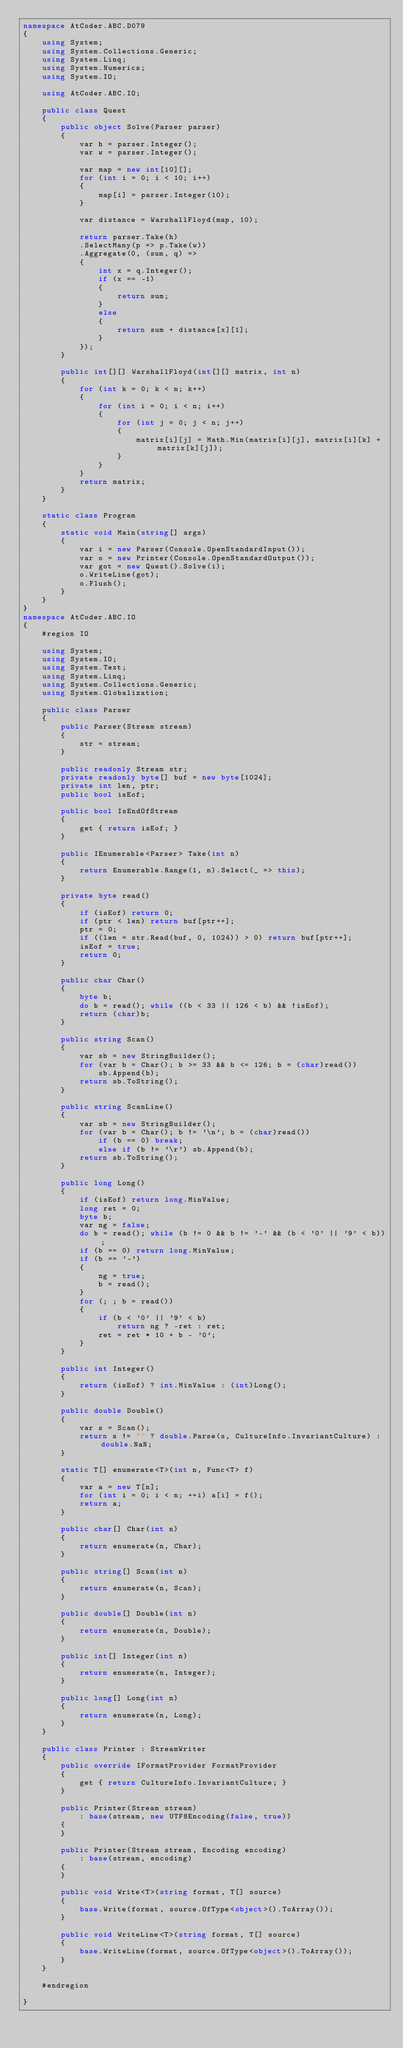<code> <loc_0><loc_0><loc_500><loc_500><_C#_>namespace AtCoder.ABC.D079
{
    using System;
    using System.Collections.Generic;
    using System.Linq;
    using System.Numerics;
    using System.IO;

    using AtCoder.ABC.IO;

    public class Quest
    {
        public object Solve(Parser parser)
        {
            var h = parser.Integer();
            var w = parser.Integer();

            var map = new int[10][];
            for (int i = 0; i < 10; i++)
            {
                map[i] = parser.Integer(10);
            }

            var distance = WarshallFloyd(map, 10);

            return parser.Take(h)
            .SelectMany(p => p.Take(w))
            .Aggregate(0, (sum, q) =>
            {
                int x = q.Integer();
                if (x == -1)
                {
                    return sum;
                }
                else
                {
                    return sum + distance[x][1];
                }
            });
        }

        public int[][] WarshallFloyd(int[][] matrix, int n)
        {
            for (int k = 0; k < n; k++)
            {
                for (int i = 0; i < n; i++)
                {
                    for (int j = 0; j < n; j++)
                    {
                        matrix[i][j] = Math.Min(matrix[i][j], matrix[i][k] + matrix[k][j]);
                    }
                }
            }
            return matrix;
        }
    }

    static class Program
    {
        static void Main(string[] args)
        {
            var i = new Parser(Console.OpenStandardInput());
            var o = new Printer(Console.OpenStandardOutput());
            var got = new Quest().Solve(i);
            o.WriteLine(got);
            o.Flush();
        }
    }
}
namespace AtCoder.ABC.IO
{
    #region IO

    using System;
    using System.IO;
    using System.Text;
    using System.Linq;
    using System.Collections.Generic;
    using System.Globalization;

    public class Parser
    {
        public Parser(Stream stream)
        {
            str = stream;
        }

        public readonly Stream str;
        private readonly byte[] buf = new byte[1024];
        private int len, ptr;
        public bool isEof;

        public bool IsEndOfStream
        {
            get { return isEof; }
        }

        public IEnumerable<Parser> Take(int n)
        {
            return Enumerable.Range(1, n).Select(_ => this);
        }

        private byte read()
        {
            if (isEof) return 0;
            if (ptr < len) return buf[ptr++];
            ptr = 0;
            if ((len = str.Read(buf, 0, 1024)) > 0) return buf[ptr++];
            isEof = true;
            return 0;
        }

        public char Char()
        {
            byte b;
            do b = read(); while ((b < 33 || 126 < b) && !isEof);
            return (char)b;
        }

        public string Scan()
        {
            var sb = new StringBuilder();
            for (var b = Char(); b >= 33 && b <= 126; b = (char)read())
                sb.Append(b);
            return sb.ToString();
        }

        public string ScanLine()
        {
            var sb = new StringBuilder();
            for (var b = Char(); b != '\n'; b = (char)read())
                if (b == 0) break;
                else if (b != '\r') sb.Append(b);
            return sb.ToString();
        }

        public long Long()
        {
            if (isEof) return long.MinValue;
            long ret = 0;
            byte b;
            var ng = false;
            do b = read(); while (b != 0 && b != '-' && (b < '0' || '9' < b));
            if (b == 0) return long.MinValue;
            if (b == '-')
            {
                ng = true;
                b = read();
            }
            for (; ; b = read())
            {
                if (b < '0' || '9' < b)
                    return ng ? -ret : ret;
                ret = ret * 10 + b - '0';
            }
        }

        public int Integer()
        {
            return (isEof) ? int.MinValue : (int)Long();
        }

        public double Double()
        {
            var s = Scan();
            return s != "" ? double.Parse(s, CultureInfo.InvariantCulture) : double.NaN;
        }

        static T[] enumerate<T>(int n, Func<T> f)
        {
            var a = new T[n];
            for (int i = 0; i < n; ++i) a[i] = f();
            return a;
        }

        public char[] Char(int n)
        {
            return enumerate(n, Char);
        }

        public string[] Scan(int n)
        {
            return enumerate(n, Scan);
        }

        public double[] Double(int n)
        {
            return enumerate(n, Double);
        }

        public int[] Integer(int n)
        {
            return enumerate(n, Integer);
        }

        public long[] Long(int n)
        {
            return enumerate(n, Long);
        }
    }

    public class Printer : StreamWriter
    {
        public override IFormatProvider FormatProvider
        {
            get { return CultureInfo.InvariantCulture; }
        }

        public Printer(Stream stream)
            : base(stream, new UTF8Encoding(false, true))
        {
        }

        public Printer(Stream stream, Encoding encoding)
            : base(stream, encoding)
        {
        }

        public void Write<T>(string format, T[] source)
        {
            base.Write(format, source.OfType<object>().ToArray());
        }

        public void WriteLine<T>(string format, T[] source)
        {
            base.WriteLine(format, source.OfType<object>().ToArray());
        }
    }

    #endregion

}</code> 